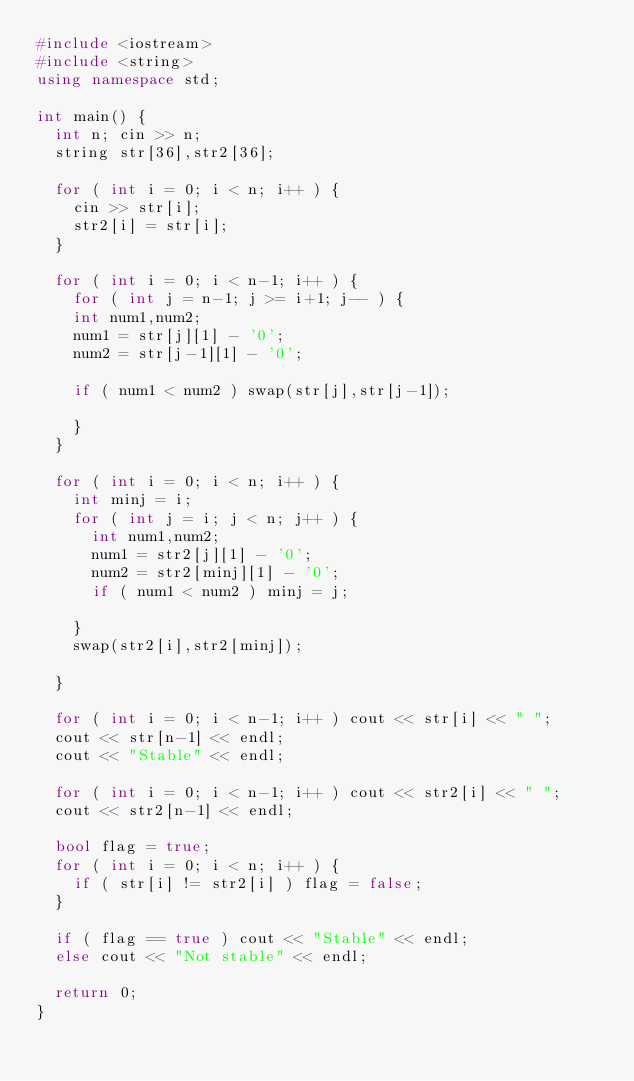Convert code to text. <code><loc_0><loc_0><loc_500><loc_500><_C++_>#include <iostream>
#include <string>
using namespace std;

int main() {
  int n; cin >> n;
  string str[36],str2[36];
  
  for ( int i = 0; i < n; i++ ) {
    cin >> str[i];
    str2[i] = str[i];
  }
  
  for ( int i = 0; i < n-1; i++ ) {
    for ( int j = n-1; j >= i+1; j-- ) {
    int num1,num2;
    num1 = str[j][1] - '0';
    num2 = str[j-1][1] - '0';
      
    if ( num1 < num2 ) swap(str[j],str[j-1]);
  
    }
  }

  for ( int i = 0; i < n; i++ ) {
    int minj = i;
    for ( int j = i; j < n; j++ ) {
      int num1,num2;
      num1 = str2[j][1] - '0';
      num2 = str2[minj][1] - '0';
      if ( num1 < num2 ) minj = j;

    }
    swap(str2[i],str2[minj]);

  }
  
  for ( int i = 0; i < n-1; i++ ) cout << str[i] << " ";
  cout << str[n-1] << endl;
  cout << "Stable" << endl;
  
  for ( int i = 0; i < n-1; i++ ) cout << str2[i] << " ";
  cout << str2[n-1] << endl;
  
  bool flag = true;
  for ( int i = 0; i < n; i++ ) {
    if ( str[i] != str2[i] ) flag = false;
  }

  if ( flag == true ) cout << "Stable" << endl;
  else cout << "Not stable" << endl;

  return 0;
}</code> 